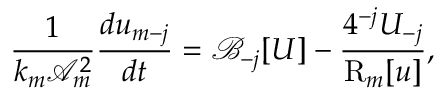Convert formula to latex. <formula><loc_0><loc_0><loc_500><loc_500>\frac { 1 } { k _ { m } \mathcal { A } _ { m } ^ { 2 } } \frac { d u _ { m - j } } { d t } = \mathcal { B } _ { - j } [ U ] - \frac { 4 ^ { - j } U _ { - j } } { R _ { m } [ u ] } ,</formula> 